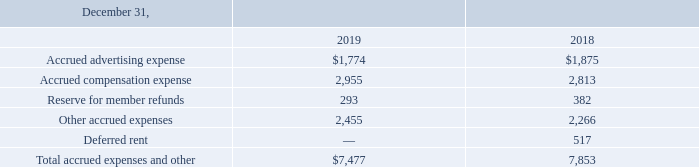Accrued expenses and other consist of the following (in thousands):
At December 31, 2019 and 2018, accounts receivable, accounts payable and accrued expenses are not measured at fair value; however, the Company believes that the carrying amounts of these assets and liabilities are a reasonable estimate of their fair value because of their relative short maturity.
What is the accrued advertising expense for 2019 and 2018 respectively?
Answer scale should be: thousand. $1,774, $1,875. What is the accrued compensation expense for 2019 and 2018 respectively?
Answer scale should be: thousand. 2,955, 2,813. What is the reserve for member refunds for 2019 and 2018 respectively?
Answer scale should be: thousand. 293, 382. What is the change in accrued compensation expense between 2018 and 2019?
Answer scale should be: thousand. 2,955-2,813
Answer: 142. What is the average reserve for member refunds for 2018 and 2019?
Answer scale should be: thousand. (293+382)/2
Answer: 337.5. What is the percentage change in the total accrued expenses and other from 2018 to 2019?
Answer scale should be: percent. (7,477-7,853)/7,853
Answer: -4.79. 